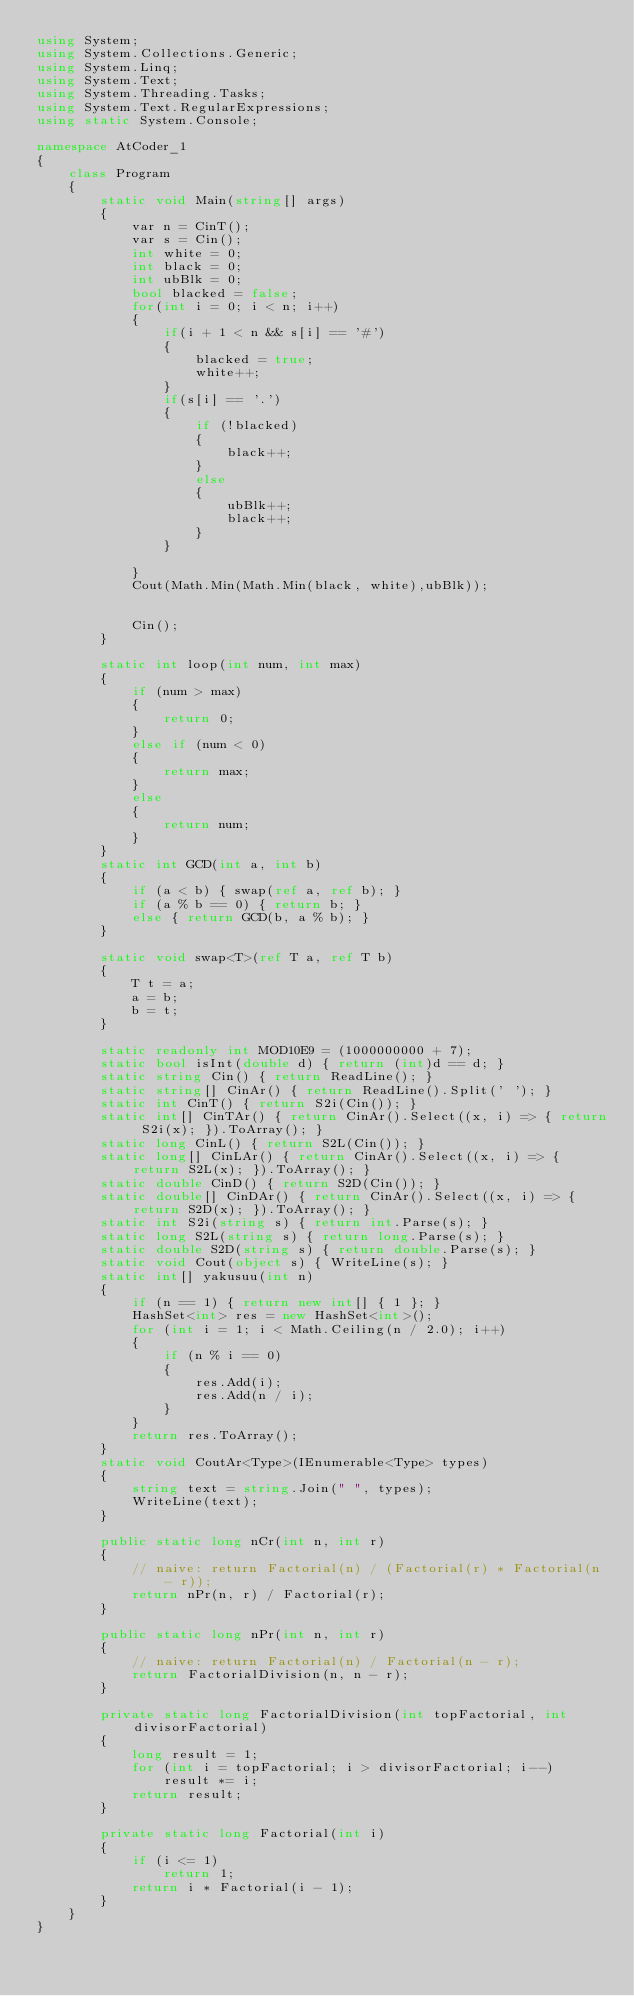<code> <loc_0><loc_0><loc_500><loc_500><_C#_>using System;
using System.Collections.Generic;
using System.Linq;
using System.Text;
using System.Threading.Tasks;
using System.Text.RegularExpressions;
using static System.Console;

namespace AtCoder_1
{
    class Program
    {
        static void Main(string[] args)
        {
            var n = CinT();
            var s = Cin();
            int white = 0;
            int black = 0;
            int ubBlk = 0;
            bool blacked = false;
            for(int i = 0; i < n; i++)
            {
                if(i + 1 < n && s[i] == '#')
                {
                    blacked = true;
                    white++;
                }
                if(s[i] == '.')
                {
                    if (!blacked)
                    {
                        black++;
                    }
                    else
                    {
                        ubBlk++;
                        black++;
                    }
                }

            }
            Cout(Math.Min(Math.Min(black, white),ubBlk));


            Cin();
        }

        static int loop(int num, int max)
        {
            if (num > max)
            {
                return 0;
            }
            else if (num < 0)
            {
                return max;
            }
            else
            {
                return num;
            }
        }
        static int GCD(int a, int b)
        {
            if (a < b) { swap(ref a, ref b); }
            if (a % b == 0) { return b; }
            else { return GCD(b, a % b); }
        }

        static void swap<T>(ref T a, ref T b)
        {
            T t = a;
            a = b;
            b = t;
        }

        static readonly int MOD10E9 = (1000000000 + 7);
        static bool isInt(double d) { return (int)d == d; }
        static string Cin() { return ReadLine(); }
        static string[] CinAr() { return ReadLine().Split(' '); }
        static int CinT() { return S2i(Cin()); }
        static int[] CinTAr() { return CinAr().Select((x, i) => { return S2i(x); }).ToArray(); }
        static long CinL() { return S2L(Cin()); }
        static long[] CinLAr() { return CinAr().Select((x, i) => { return S2L(x); }).ToArray(); }
        static double CinD() { return S2D(Cin()); }
        static double[] CinDAr() { return CinAr().Select((x, i) => { return S2D(x); }).ToArray(); }
        static int S2i(string s) { return int.Parse(s); }
        static long S2L(string s) { return long.Parse(s); }
        static double S2D(string s) { return double.Parse(s); }
        static void Cout(object s) { WriteLine(s); }
        static int[] yakusuu(int n)
        {
            if (n == 1) { return new int[] { 1 }; }
            HashSet<int> res = new HashSet<int>();
            for (int i = 1; i < Math.Ceiling(n / 2.0); i++)
            {
                if (n % i == 0)
                {
                    res.Add(i);
                    res.Add(n / i);
                }
            }
            return res.ToArray();
        }
        static void CoutAr<Type>(IEnumerable<Type> types)
        {
            string text = string.Join(" ", types);
            WriteLine(text);
        }

        public static long nCr(int n, int r)
        {
            // naive: return Factorial(n) / (Factorial(r) * Factorial(n - r));
            return nPr(n, r) / Factorial(r);
        }

        public static long nPr(int n, int r)
        {
            // naive: return Factorial(n) / Factorial(n - r);
            return FactorialDivision(n, n - r);
        }

        private static long FactorialDivision(int topFactorial, int divisorFactorial)
        {
            long result = 1;
            for (int i = topFactorial; i > divisorFactorial; i--)
                result *= i;
            return result;
        }

        private static long Factorial(int i)
        {
            if (i <= 1)
                return 1;
            return i * Factorial(i - 1);
        }
    }
}
</code> 